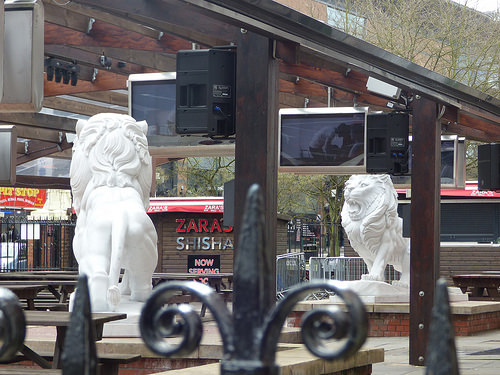<image>
Is there a lion above the fence? No. The lion is not positioned above the fence. The vertical arrangement shows a different relationship. 